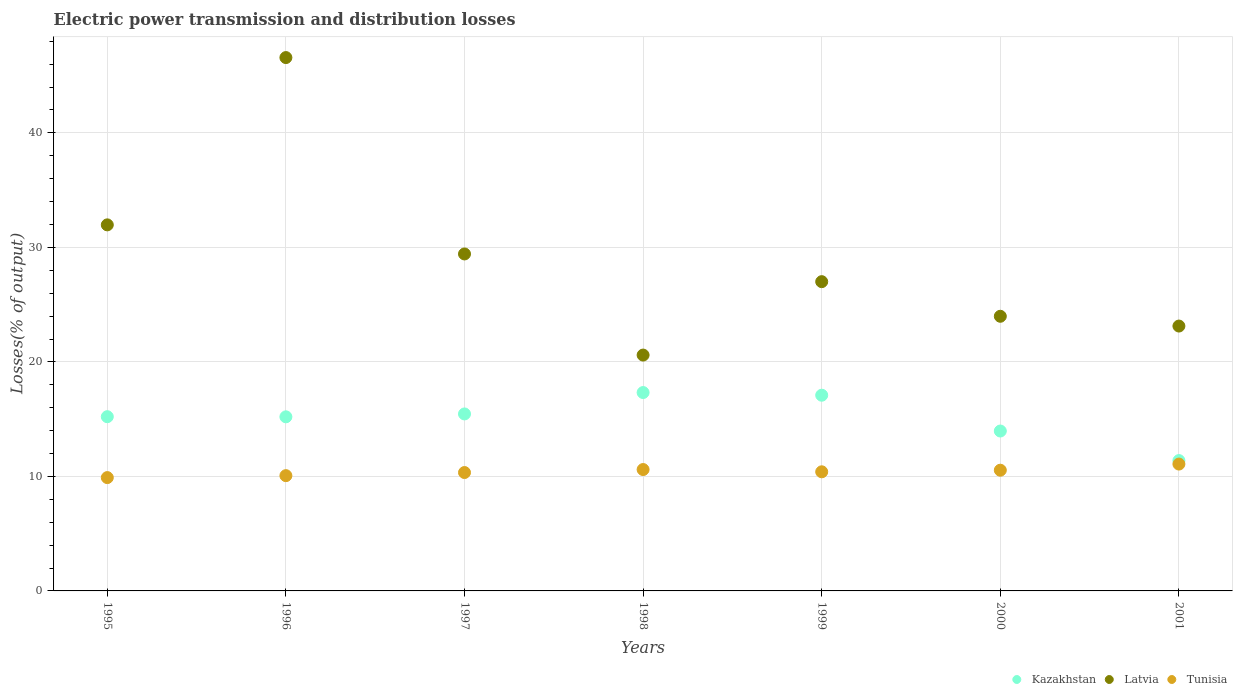Is the number of dotlines equal to the number of legend labels?
Keep it short and to the point. Yes. What is the electric power transmission and distribution losses in Kazakhstan in 1998?
Offer a very short reply. 17.32. Across all years, what is the maximum electric power transmission and distribution losses in Kazakhstan?
Ensure brevity in your answer.  17.32. Across all years, what is the minimum electric power transmission and distribution losses in Tunisia?
Ensure brevity in your answer.  9.9. In which year was the electric power transmission and distribution losses in Kazakhstan maximum?
Keep it short and to the point. 1998. What is the total electric power transmission and distribution losses in Latvia in the graph?
Your answer should be compact. 202.69. What is the difference between the electric power transmission and distribution losses in Kazakhstan in 1995 and that in 2001?
Provide a short and direct response. 3.83. What is the difference between the electric power transmission and distribution losses in Tunisia in 1995 and the electric power transmission and distribution losses in Kazakhstan in 2000?
Offer a terse response. -4.07. What is the average electric power transmission and distribution losses in Kazakhstan per year?
Your answer should be very brief. 15.09. In the year 1997, what is the difference between the electric power transmission and distribution losses in Tunisia and electric power transmission and distribution losses in Latvia?
Your response must be concise. -19.09. What is the ratio of the electric power transmission and distribution losses in Latvia in 1996 to that in 1999?
Offer a terse response. 1.72. What is the difference between the highest and the second highest electric power transmission and distribution losses in Latvia?
Your answer should be very brief. 14.61. What is the difference between the highest and the lowest electric power transmission and distribution losses in Tunisia?
Your response must be concise. 1.18. Is it the case that in every year, the sum of the electric power transmission and distribution losses in Latvia and electric power transmission and distribution losses in Tunisia  is greater than the electric power transmission and distribution losses in Kazakhstan?
Give a very brief answer. Yes. Is the electric power transmission and distribution losses in Latvia strictly greater than the electric power transmission and distribution losses in Tunisia over the years?
Ensure brevity in your answer.  Yes. How many dotlines are there?
Your answer should be very brief. 3. How many years are there in the graph?
Offer a very short reply. 7. What is the difference between two consecutive major ticks on the Y-axis?
Offer a very short reply. 10. Does the graph contain any zero values?
Offer a terse response. No. Where does the legend appear in the graph?
Offer a terse response. Bottom right. How many legend labels are there?
Your answer should be very brief. 3. How are the legend labels stacked?
Your answer should be compact. Horizontal. What is the title of the graph?
Offer a terse response. Electric power transmission and distribution losses. What is the label or title of the X-axis?
Your response must be concise. Years. What is the label or title of the Y-axis?
Give a very brief answer. Losses(% of output). What is the Losses(% of output) in Kazakhstan in 1995?
Offer a terse response. 15.22. What is the Losses(% of output) of Latvia in 1995?
Make the answer very short. 31.97. What is the Losses(% of output) of Tunisia in 1995?
Provide a short and direct response. 9.9. What is the Losses(% of output) in Kazakhstan in 1996?
Your answer should be compact. 15.2. What is the Losses(% of output) of Latvia in 1996?
Keep it short and to the point. 46.58. What is the Losses(% of output) in Tunisia in 1996?
Your answer should be very brief. 10.07. What is the Losses(% of output) of Kazakhstan in 1997?
Offer a terse response. 15.46. What is the Losses(% of output) in Latvia in 1997?
Ensure brevity in your answer.  29.43. What is the Losses(% of output) of Tunisia in 1997?
Your answer should be very brief. 10.34. What is the Losses(% of output) in Kazakhstan in 1998?
Ensure brevity in your answer.  17.32. What is the Losses(% of output) in Latvia in 1998?
Keep it short and to the point. 20.6. What is the Losses(% of output) of Tunisia in 1998?
Your answer should be very brief. 10.6. What is the Losses(% of output) of Kazakhstan in 1999?
Keep it short and to the point. 17.09. What is the Losses(% of output) of Latvia in 1999?
Provide a succinct answer. 27.01. What is the Losses(% of output) of Tunisia in 1999?
Offer a very short reply. 10.4. What is the Losses(% of output) of Kazakhstan in 2000?
Offer a very short reply. 13.96. What is the Losses(% of output) in Latvia in 2000?
Give a very brief answer. 23.98. What is the Losses(% of output) in Tunisia in 2000?
Offer a terse response. 10.54. What is the Losses(% of output) of Kazakhstan in 2001?
Ensure brevity in your answer.  11.38. What is the Losses(% of output) of Latvia in 2001?
Keep it short and to the point. 23.13. What is the Losses(% of output) of Tunisia in 2001?
Your answer should be very brief. 11.08. Across all years, what is the maximum Losses(% of output) in Kazakhstan?
Your answer should be very brief. 17.32. Across all years, what is the maximum Losses(% of output) in Latvia?
Give a very brief answer. 46.58. Across all years, what is the maximum Losses(% of output) of Tunisia?
Give a very brief answer. 11.08. Across all years, what is the minimum Losses(% of output) in Kazakhstan?
Your answer should be compact. 11.38. Across all years, what is the minimum Losses(% of output) in Latvia?
Ensure brevity in your answer.  20.6. Across all years, what is the minimum Losses(% of output) in Tunisia?
Offer a terse response. 9.9. What is the total Losses(% of output) of Kazakhstan in the graph?
Offer a terse response. 105.64. What is the total Losses(% of output) of Latvia in the graph?
Your answer should be compact. 202.69. What is the total Losses(% of output) of Tunisia in the graph?
Provide a succinct answer. 72.92. What is the difference between the Losses(% of output) in Kazakhstan in 1995 and that in 1996?
Your response must be concise. 0.01. What is the difference between the Losses(% of output) in Latvia in 1995 and that in 1996?
Your response must be concise. -14.61. What is the difference between the Losses(% of output) of Tunisia in 1995 and that in 1996?
Your answer should be very brief. -0.17. What is the difference between the Losses(% of output) in Kazakhstan in 1995 and that in 1997?
Give a very brief answer. -0.24. What is the difference between the Losses(% of output) of Latvia in 1995 and that in 1997?
Keep it short and to the point. 2.54. What is the difference between the Losses(% of output) in Tunisia in 1995 and that in 1997?
Keep it short and to the point. -0.44. What is the difference between the Losses(% of output) in Kazakhstan in 1995 and that in 1998?
Provide a short and direct response. -2.11. What is the difference between the Losses(% of output) of Latvia in 1995 and that in 1998?
Your answer should be very brief. 11.37. What is the difference between the Losses(% of output) of Tunisia in 1995 and that in 1998?
Your answer should be very brief. -0.7. What is the difference between the Losses(% of output) of Kazakhstan in 1995 and that in 1999?
Offer a terse response. -1.88. What is the difference between the Losses(% of output) in Latvia in 1995 and that in 1999?
Keep it short and to the point. 4.96. What is the difference between the Losses(% of output) in Tunisia in 1995 and that in 1999?
Your answer should be very brief. -0.51. What is the difference between the Losses(% of output) in Kazakhstan in 1995 and that in 2000?
Ensure brevity in your answer.  1.25. What is the difference between the Losses(% of output) in Latvia in 1995 and that in 2000?
Ensure brevity in your answer.  7.98. What is the difference between the Losses(% of output) in Tunisia in 1995 and that in 2000?
Offer a very short reply. -0.64. What is the difference between the Losses(% of output) in Kazakhstan in 1995 and that in 2001?
Offer a very short reply. 3.83. What is the difference between the Losses(% of output) in Latvia in 1995 and that in 2001?
Make the answer very short. 8.84. What is the difference between the Losses(% of output) of Tunisia in 1995 and that in 2001?
Your response must be concise. -1.18. What is the difference between the Losses(% of output) in Kazakhstan in 1996 and that in 1997?
Provide a short and direct response. -0.25. What is the difference between the Losses(% of output) in Latvia in 1996 and that in 1997?
Offer a terse response. 17.15. What is the difference between the Losses(% of output) in Tunisia in 1996 and that in 1997?
Your answer should be compact. -0.27. What is the difference between the Losses(% of output) in Kazakhstan in 1996 and that in 1998?
Offer a terse response. -2.12. What is the difference between the Losses(% of output) of Latvia in 1996 and that in 1998?
Provide a succinct answer. 25.98. What is the difference between the Losses(% of output) of Tunisia in 1996 and that in 1998?
Keep it short and to the point. -0.53. What is the difference between the Losses(% of output) of Kazakhstan in 1996 and that in 1999?
Ensure brevity in your answer.  -1.89. What is the difference between the Losses(% of output) in Latvia in 1996 and that in 1999?
Keep it short and to the point. 19.57. What is the difference between the Losses(% of output) of Tunisia in 1996 and that in 1999?
Provide a succinct answer. -0.34. What is the difference between the Losses(% of output) in Kazakhstan in 1996 and that in 2000?
Offer a terse response. 1.24. What is the difference between the Losses(% of output) of Latvia in 1996 and that in 2000?
Give a very brief answer. 22.59. What is the difference between the Losses(% of output) in Tunisia in 1996 and that in 2000?
Offer a very short reply. -0.47. What is the difference between the Losses(% of output) in Kazakhstan in 1996 and that in 2001?
Provide a short and direct response. 3.82. What is the difference between the Losses(% of output) of Latvia in 1996 and that in 2001?
Provide a succinct answer. 23.45. What is the difference between the Losses(% of output) in Tunisia in 1996 and that in 2001?
Give a very brief answer. -1.01. What is the difference between the Losses(% of output) in Kazakhstan in 1997 and that in 1998?
Give a very brief answer. -1.87. What is the difference between the Losses(% of output) of Latvia in 1997 and that in 1998?
Offer a very short reply. 8.83. What is the difference between the Losses(% of output) in Tunisia in 1997 and that in 1998?
Provide a short and direct response. -0.26. What is the difference between the Losses(% of output) of Kazakhstan in 1997 and that in 1999?
Your answer should be very brief. -1.64. What is the difference between the Losses(% of output) of Latvia in 1997 and that in 1999?
Offer a terse response. 2.42. What is the difference between the Losses(% of output) of Tunisia in 1997 and that in 1999?
Provide a short and direct response. -0.06. What is the difference between the Losses(% of output) in Kazakhstan in 1997 and that in 2000?
Make the answer very short. 1.49. What is the difference between the Losses(% of output) of Latvia in 1997 and that in 2000?
Your answer should be very brief. 5.44. What is the difference between the Losses(% of output) of Tunisia in 1997 and that in 2000?
Offer a terse response. -0.2. What is the difference between the Losses(% of output) of Kazakhstan in 1997 and that in 2001?
Provide a short and direct response. 4.07. What is the difference between the Losses(% of output) of Latvia in 1997 and that in 2001?
Offer a terse response. 6.3. What is the difference between the Losses(% of output) in Tunisia in 1997 and that in 2001?
Ensure brevity in your answer.  -0.74. What is the difference between the Losses(% of output) of Kazakhstan in 1998 and that in 1999?
Offer a terse response. 0.23. What is the difference between the Losses(% of output) in Latvia in 1998 and that in 1999?
Keep it short and to the point. -6.41. What is the difference between the Losses(% of output) in Tunisia in 1998 and that in 1999?
Provide a short and direct response. 0.2. What is the difference between the Losses(% of output) in Kazakhstan in 1998 and that in 2000?
Offer a very short reply. 3.36. What is the difference between the Losses(% of output) of Latvia in 1998 and that in 2000?
Offer a very short reply. -3.39. What is the difference between the Losses(% of output) of Tunisia in 1998 and that in 2000?
Offer a terse response. 0.06. What is the difference between the Losses(% of output) in Kazakhstan in 1998 and that in 2001?
Ensure brevity in your answer.  5.94. What is the difference between the Losses(% of output) in Latvia in 1998 and that in 2001?
Your response must be concise. -2.53. What is the difference between the Losses(% of output) of Tunisia in 1998 and that in 2001?
Your answer should be very brief. -0.48. What is the difference between the Losses(% of output) of Kazakhstan in 1999 and that in 2000?
Your response must be concise. 3.13. What is the difference between the Losses(% of output) in Latvia in 1999 and that in 2000?
Your answer should be very brief. 3.02. What is the difference between the Losses(% of output) in Tunisia in 1999 and that in 2000?
Offer a very short reply. -0.14. What is the difference between the Losses(% of output) of Kazakhstan in 1999 and that in 2001?
Ensure brevity in your answer.  5.71. What is the difference between the Losses(% of output) of Latvia in 1999 and that in 2001?
Offer a terse response. 3.88. What is the difference between the Losses(% of output) in Tunisia in 1999 and that in 2001?
Offer a terse response. -0.67. What is the difference between the Losses(% of output) in Kazakhstan in 2000 and that in 2001?
Offer a terse response. 2.58. What is the difference between the Losses(% of output) of Latvia in 2000 and that in 2001?
Ensure brevity in your answer.  0.85. What is the difference between the Losses(% of output) in Tunisia in 2000 and that in 2001?
Give a very brief answer. -0.54. What is the difference between the Losses(% of output) in Kazakhstan in 1995 and the Losses(% of output) in Latvia in 1996?
Your answer should be very brief. -31.36. What is the difference between the Losses(% of output) of Kazakhstan in 1995 and the Losses(% of output) of Tunisia in 1996?
Make the answer very short. 5.15. What is the difference between the Losses(% of output) of Latvia in 1995 and the Losses(% of output) of Tunisia in 1996?
Ensure brevity in your answer.  21.9. What is the difference between the Losses(% of output) of Kazakhstan in 1995 and the Losses(% of output) of Latvia in 1997?
Your answer should be very brief. -14.21. What is the difference between the Losses(% of output) of Kazakhstan in 1995 and the Losses(% of output) of Tunisia in 1997?
Offer a terse response. 4.88. What is the difference between the Losses(% of output) in Latvia in 1995 and the Losses(% of output) in Tunisia in 1997?
Offer a very short reply. 21.63. What is the difference between the Losses(% of output) in Kazakhstan in 1995 and the Losses(% of output) in Latvia in 1998?
Your response must be concise. -5.38. What is the difference between the Losses(% of output) in Kazakhstan in 1995 and the Losses(% of output) in Tunisia in 1998?
Give a very brief answer. 4.62. What is the difference between the Losses(% of output) in Latvia in 1995 and the Losses(% of output) in Tunisia in 1998?
Your response must be concise. 21.37. What is the difference between the Losses(% of output) in Kazakhstan in 1995 and the Losses(% of output) in Latvia in 1999?
Ensure brevity in your answer.  -11.79. What is the difference between the Losses(% of output) in Kazakhstan in 1995 and the Losses(% of output) in Tunisia in 1999?
Offer a terse response. 4.81. What is the difference between the Losses(% of output) of Latvia in 1995 and the Losses(% of output) of Tunisia in 1999?
Provide a short and direct response. 21.56. What is the difference between the Losses(% of output) of Kazakhstan in 1995 and the Losses(% of output) of Latvia in 2000?
Your answer should be compact. -8.77. What is the difference between the Losses(% of output) of Kazakhstan in 1995 and the Losses(% of output) of Tunisia in 2000?
Give a very brief answer. 4.67. What is the difference between the Losses(% of output) in Latvia in 1995 and the Losses(% of output) in Tunisia in 2000?
Ensure brevity in your answer.  21.43. What is the difference between the Losses(% of output) of Kazakhstan in 1995 and the Losses(% of output) of Latvia in 2001?
Provide a succinct answer. -7.92. What is the difference between the Losses(% of output) in Kazakhstan in 1995 and the Losses(% of output) in Tunisia in 2001?
Give a very brief answer. 4.14. What is the difference between the Losses(% of output) of Latvia in 1995 and the Losses(% of output) of Tunisia in 2001?
Your answer should be compact. 20.89. What is the difference between the Losses(% of output) in Kazakhstan in 1996 and the Losses(% of output) in Latvia in 1997?
Ensure brevity in your answer.  -14.22. What is the difference between the Losses(% of output) of Kazakhstan in 1996 and the Losses(% of output) of Tunisia in 1997?
Your answer should be very brief. 4.87. What is the difference between the Losses(% of output) of Latvia in 1996 and the Losses(% of output) of Tunisia in 1997?
Your response must be concise. 36.24. What is the difference between the Losses(% of output) in Kazakhstan in 1996 and the Losses(% of output) in Latvia in 1998?
Make the answer very short. -5.39. What is the difference between the Losses(% of output) of Kazakhstan in 1996 and the Losses(% of output) of Tunisia in 1998?
Keep it short and to the point. 4.6. What is the difference between the Losses(% of output) of Latvia in 1996 and the Losses(% of output) of Tunisia in 1998?
Your answer should be very brief. 35.98. What is the difference between the Losses(% of output) in Kazakhstan in 1996 and the Losses(% of output) in Latvia in 1999?
Your answer should be compact. -11.8. What is the difference between the Losses(% of output) of Kazakhstan in 1996 and the Losses(% of output) of Tunisia in 1999?
Offer a very short reply. 4.8. What is the difference between the Losses(% of output) of Latvia in 1996 and the Losses(% of output) of Tunisia in 1999?
Keep it short and to the point. 36.17. What is the difference between the Losses(% of output) in Kazakhstan in 1996 and the Losses(% of output) in Latvia in 2000?
Your answer should be very brief. -8.78. What is the difference between the Losses(% of output) of Kazakhstan in 1996 and the Losses(% of output) of Tunisia in 2000?
Provide a short and direct response. 4.66. What is the difference between the Losses(% of output) in Latvia in 1996 and the Losses(% of output) in Tunisia in 2000?
Offer a very short reply. 36.04. What is the difference between the Losses(% of output) of Kazakhstan in 1996 and the Losses(% of output) of Latvia in 2001?
Provide a succinct answer. -7.93. What is the difference between the Losses(% of output) in Kazakhstan in 1996 and the Losses(% of output) in Tunisia in 2001?
Provide a short and direct response. 4.13. What is the difference between the Losses(% of output) of Latvia in 1996 and the Losses(% of output) of Tunisia in 2001?
Ensure brevity in your answer.  35.5. What is the difference between the Losses(% of output) of Kazakhstan in 1997 and the Losses(% of output) of Latvia in 1998?
Make the answer very short. -5.14. What is the difference between the Losses(% of output) in Kazakhstan in 1997 and the Losses(% of output) in Tunisia in 1998?
Your answer should be compact. 4.86. What is the difference between the Losses(% of output) of Latvia in 1997 and the Losses(% of output) of Tunisia in 1998?
Keep it short and to the point. 18.83. What is the difference between the Losses(% of output) of Kazakhstan in 1997 and the Losses(% of output) of Latvia in 1999?
Provide a succinct answer. -11.55. What is the difference between the Losses(% of output) in Kazakhstan in 1997 and the Losses(% of output) in Tunisia in 1999?
Provide a short and direct response. 5.05. What is the difference between the Losses(% of output) in Latvia in 1997 and the Losses(% of output) in Tunisia in 1999?
Provide a succinct answer. 19.02. What is the difference between the Losses(% of output) in Kazakhstan in 1997 and the Losses(% of output) in Latvia in 2000?
Your answer should be very brief. -8.53. What is the difference between the Losses(% of output) of Kazakhstan in 1997 and the Losses(% of output) of Tunisia in 2000?
Your response must be concise. 4.91. What is the difference between the Losses(% of output) of Latvia in 1997 and the Losses(% of output) of Tunisia in 2000?
Offer a terse response. 18.89. What is the difference between the Losses(% of output) in Kazakhstan in 1997 and the Losses(% of output) in Latvia in 2001?
Ensure brevity in your answer.  -7.68. What is the difference between the Losses(% of output) of Kazakhstan in 1997 and the Losses(% of output) of Tunisia in 2001?
Offer a very short reply. 4.38. What is the difference between the Losses(% of output) in Latvia in 1997 and the Losses(% of output) in Tunisia in 2001?
Your answer should be very brief. 18.35. What is the difference between the Losses(% of output) of Kazakhstan in 1998 and the Losses(% of output) of Latvia in 1999?
Ensure brevity in your answer.  -9.68. What is the difference between the Losses(% of output) of Kazakhstan in 1998 and the Losses(% of output) of Tunisia in 1999?
Your answer should be very brief. 6.92. What is the difference between the Losses(% of output) of Latvia in 1998 and the Losses(% of output) of Tunisia in 1999?
Your answer should be compact. 10.19. What is the difference between the Losses(% of output) of Kazakhstan in 1998 and the Losses(% of output) of Latvia in 2000?
Make the answer very short. -6.66. What is the difference between the Losses(% of output) in Kazakhstan in 1998 and the Losses(% of output) in Tunisia in 2000?
Provide a short and direct response. 6.78. What is the difference between the Losses(% of output) of Latvia in 1998 and the Losses(% of output) of Tunisia in 2000?
Provide a short and direct response. 10.06. What is the difference between the Losses(% of output) in Kazakhstan in 1998 and the Losses(% of output) in Latvia in 2001?
Provide a short and direct response. -5.81. What is the difference between the Losses(% of output) in Kazakhstan in 1998 and the Losses(% of output) in Tunisia in 2001?
Your answer should be compact. 6.25. What is the difference between the Losses(% of output) of Latvia in 1998 and the Losses(% of output) of Tunisia in 2001?
Keep it short and to the point. 9.52. What is the difference between the Losses(% of output) of Kazakhstan in 1999 and the Losses(% of output) of Latvia in 2000?
Ensure brevity in your answer.  -6.89. What is the difference between the Losses(% of output) of Kazakhstan in 1999 and the Losses(% of output) of Tunisia in 2000?
Your answer should be very brief. 6.55. What is the difference between the Losses(% of output) of Latvia in 1999 and the Losses(% of output) of Tunisia in 2000?
Offer a very short reply. 16.47. What is the difference between the Losses(% of output) of Kazakhstan in 1999 and the Losses(% of output) of Latvia in 2001?
Ensure brevity in your answer.  -6.04. What is the difference between the Losses(% of output) in Kazakhstan in 1999 and the Losses(% of output) in Tunisia in 2001?
Ensure brevity in your answer.  6.01. What is the difference between the Losses(% of output) in Latvia in 1999 and the Losses(% of output) in Tunisia in 2001?
Offer a terse response. 15.93. What is the difference between the Losses(% of output) in Kazakhstan in 2000 and the Losses(% of output) in Latvia in 2001?
Your response must be concise. -9.17. What is the difference between the Losses(% of output) in Kazakhstan in 2000 and the Losses(% of output) in Tunisia in 2001?
Your answer should be very brief. 2.89. What is the difference between the Losses(% of output) of Latvia in 2000 and the Losses(% of output) of Tunisia in 2001?
Your response must be concise. 12.91. What is the average Losses(% of output) in Kazakhstan per year?
Provide a succinct answer. 15.09. What is the average Losses(% of output) in Latvia per year?
Your response must be concise. 28.96. What is the average Losses(% of output) in Tunisia per year?
Provide a succinct answer. 10.42. In the year 1995, what is the difference between the Losses(% of output) of Kazakhstan and Losses(% of output) of Latvia?
Offer a terse response. -16.75. In the year 1995, what is the difference between the Losses(% of output) of Kazakhstan and Losses(% of output) of Tunisia?
Your answer should be compact. 5.32. In the year 1995, what is the difference between the Losses(% of output) in Latvia and Losses(% of output) in Tunisia?
Provide a short and direct response. 22.07. In the year 1996, what is the difference between the Losses(% of output) in Kazakhstan and Losses(% of output) in Latvia?
Your answer should be compact. -31.37. In the year 1996, what is the difference between the Losses(% of output) of Kazakhstan and Losses(% of output) of Tunisia?
Offer a terse response. 5.14. In the year 1996, what is the difference between the Losses(% of output) of Latvia and Losses(% of output) of Tunisia?
Provide a succinct answer. 36.51. In the year 1997, what is the difference between the Losses(% of output) of Kazakhstan and Losses(% of output) of Latvia?
Offer a terse response. -13.97. In the year 1997, what is the difference between the Losses(% of output) of Kazakhstan and Losses(% of output) of Tunisia?
Provide a short and direct response. 5.12. In the year 1997, what is the difference between the Losses(% of output) in Latvia and Losses(% of output) in Tunisia?
Your answer should be very brief. 19.09. In the year 1998, what is the difference between the Losses(% of output) of Kazakhstan and Losses(% of output) of Latvia?
Your answer should be very brief. -3.27. In the year 1998, what is the difference between the Losses(% of output) in Kazakhstan and Losses(% of output) in Tunisia?
Make the answer very short. 6.72. In the year 1998, what is the difference between the Losses(% of output) in Latvia and Losses(% of output) in Tunisia?
Make the answer very short. 10. In the year 1999, what is the difference between the Losses(% of output) in Kazakhstan and Losses(% of output) in Latvia?
Make the answer very short. -9.92. In the year 1999, what is the difference between the Losses(% of output) in Kazakhstan and Losses(% of output) in Tunisia?
Ensure brevity in your answer.  6.69. In the year 1999, what is the difference between the Losses(% of output) in Latvia and Losses(% of output) in Tunisia?
Provide a succinct answer. 16.6. In the year 2000, what is the difference between the Losses(% of output) of Kazakhstan and Losses(% of output) of Latvia?
Ensure brevity in your answer.  -10.02. In the year 2000, what is the difference between the Losses(% of output) of Kazakhstan and Losses(% of output) of Tunisia?
Ensure brevity in your answer.  3.42. In the year 2000, what is the difference between the Losses(% of output) in Latvia and Losses(% of output) in Tunisia?
Offer a very short reply. 13.44. In the year 2001, what is the difference between the Losses(% of output) of Kazakhstan and Losses(% of output) of Latvia?
Make the answer very short. -11.75. In the year 2001, what is the difference between the Losses(% of output) of Kazakhstan and Losses(% of output) of Tunisia?
Offer a terse response. 0.3. In the year 2001, what is the difference between the Losses(% of output) of Latvia and Losses(% of output) of Tunisia?
Your response must be concise. 12.05. What is the ratio of the Losses(% of output) of Latvia in 1995 to that in 1996?
Your answer should be very brief. 0.69. What is the ratio of the Losses(% of output) of Tunisia in 1995 to that in 1996?
Offer a terse response. 0.98. What is the ratio of the Losses(% of output) of Kazakhstan in 1995 to that in 1997?
Offer a terse response. 0.98. What is the ratio of the Losses(% of output) in Latvia in 1995 to that in 1997?
Offer a terse response. 1.09. What is the ratio of the Losses(% of output) in Tunisia in 1995 to that in 1997?
Offer a terse response. 0.96. What is the ratio of the Losses(% of output) of Kazakhstan in 1995 to that in 1998?
Provide a short and direct response. 0.88. What is the ratio of the Losses(% of output) of Latvia in 1995 to that in 1998?
Offer a terse response. 1.55. What is the ratio of the Losses(% of output) of Tunisia in 1995 to that in 1998?
Your answer should be compact. 0.93. What is the ratio of the Losses(% of output) in Kazakhstan in 1995 to that in 1999?
Your answer should be very brief. 0.89. What is the ratio of the Losses(% of output) in Latvia in 1995 to that in 1999?
Offer a terse response. 1.18. What is the ratio of the Losses(% of output) in Tunisia in 1995 to that in 1999?
Ensure brevity in your answer.  0.95. What is the ratio of the Losses(% of output) in Kazakhstan in 1995 to that in 2000?
Make the answer very short. 1.09. What is the ratio of the Losses(% of output) in Latvia in 1995 to that in 2000?
Give a very brief answer. 1.33. What is the ratio of the Losses(% of output) in Tunisia in 1995 to that in 2000?
Your answer should be compact. 0.94. What is the ratio of the Losses(% of output) of Kazakhstan in 1995 to that in 2001?
Your answer should be compact. 1.34. What is the ratio of the Losses(% of output) in Latvia in 1995 to that in 2001?
Provide a succinct answer. 1.38. What is the ratio of the Losses(% of output) in Tunisia in 1995 to that in 2001?
Your answer should be compact. 0.89. What is the ratio of the Losses(% of output) of Kazakhstan in 1996 to that in 1997?
Your response must be concise. 0.98. What is the ratio of the Losses(% of output) in Latvia in 1996 to that in 1997?
Provide a succinct answer. 1.58. What is the ratio of the Losses(% of output) of Tunisia in 1996 to that in 1997?
Your answer should be very brief. 0.97. What is the ratio of the Losses(% of output) in Kazakhstan in 1996 to that in 1998?
Provide a short and direct response. 0.88. What is the ratio of the Losses(% of output) of Latvia in 1996 to that in 1998?
Ensure brevity in your answer.  2.26. What is the ratio of the Losses(% of output) of Tunisia in 1996 to that in 1998?
Your answer should be very brief. 0.95. What is the ratio of the Losses(% of output) of Kazakhstan in 1996 to that in 1999?
Make the answer very short. 0.89. What is the ratio of the Losses(% of output) of Latvia in 1996 to that in 1999?
Offer a very short reply. 1.72. What is the ratio of the Losses(% of output) in Tunisia in 1996 to that in 1999?
Your answer should be compact. 0.97. What is the ratio of the Losses(% of output) in Kazakhstan in 1996 to that in 2000?
Provide a short and direct response. 1.09. What is the ratio of the Losses(% of output) in Latvia in 1996 to that in 2000?
Your answer should be very brief. 1.94. What is the ratio of the Losses(% of output) of Tunisia in 1996 to that in 2000?
Provide a short and direct response. 0.95. What is the ratio of the Losses(% of output) of Kazakhstan in 1996 to that in 2001?
Your answer should be very brief. 1.34. What is the ratio of the Losses(% of output) in Latvia in 1996 to that in 2001?
Offer a terse response. 2.01. What is the ratio of the Losses(% of output) of Tunisia in 1996 to that in 2001?
Keep it short and to the point. 0.91. What is the ratio of the Losses(% of output) of Kazakhstan in 1997 to that in 1998?
Give a very brief answer. 0.89. What is the ratio of the Losses(% of output) of Latvia in 1997 to that in 1998?
Provide a short and direct response. 1.43. What is the ratio of the Losses(% of output) of Tunisia in 1997 to that in 1998?
Keep it short and to the point. 0.98. What is the ratio of the Losses(% of output) in Kazakhstan in 1997 to that in 1999?
Keep it short and to the point. 0.9. What is the ratio of the Losses(% of output) of Latvia in 1997 to that in 1999?
Offer a very short reply. 1.09. What is the ratio of the Losses(% of output) of Kazakhstan in 1997 to that in 2000?
Ensure brevity in your answer.  1.11. What is the ratio of the Losses(% of output) in Latvia in 1997 to that in 2000?
Make the answer very short. 1.23. What is the ratio of the Losses(% of output) in Tunisia in 1997 to that in 2000?
Ensure brevity in your answer.  0.98. What is the ratio of the Losses(% of output) of Kazakhstan in 1997 to that in 2001?
Provide a succinct answer. 1.36. What is the ratio of the Losses(% of output) of Latvia in 1997 to that in 2001?
Your answer should be very brief. 1.27. What is the ratio of the Losses(% of output) in Tunisia in 1997 to that in 2001?
Offer a very short reply. 0.93. What is the ratio of the Losses(% of output) of Kazakhstan in 1998 to that in 1999?
Make the answer very short. 1.01. What is the ratio of the Losses(% of output) in Latvia in 1998 to that in 1999?
Offer a terse response. 0.76. What is the ratio of the Losses(% of output) of Tunisia in 1998 to that in 1999?
Provide a short and direct response. 1.02. What is the ratio of the Losses(% of output) of Kazakhstan in 1998 to that in 2000?
Ensure brevity in your answer.  1.24. What is the ratio of the Losses(% of output) of Latvia in 1998 to that in 2000?
Offer a terse response. 0.86. What is the ratio of the Losses(% of output) in Tunisia in 1998 to that in 2000?
Make the answer very short. 1.01. What is the ratio of the Losses(% of output) in Kazakhstan in 1998 to that in 2001?
Give a very brief answer. 1.52. What is the ratio of the Losses(% of output) of Latvia in 1998 to that in 2001?
Provide a short and direct response. 0.89. What is the ratio of the Losses(% of output) in Tunisia in 1998 to that in 2001?
Your answer should be compact. 0.96. What is the ratio of the Losses(% of output) of Kazakhstan in 1999 to that in 2000?
Offer a very short reply. 1.22. What is the ratio of the Losses(% of output) of Latvia in 1999 to that in 2000?
Offer a very short reply. 1.13. What is the ratio of the Losses(% of output) of Tunisia in 1999 to that in 2000?
Your answer should be compact. 0.99. What is the ratio of the Losses(% of output) in Kazakhstan in 1999 to that in 2001?
Give a very brief answer. 1.5. What is the ratio of the Losses(% of output) in Latvia in 1999 to that in 2001?
Your response must be concise. 1.17. What is the ratio of the Losses(% of output) in Tunisia in 1999 to that in 2001?
Offer a very short reply. 0.94. What is the ratio of the Losses(% of output) of Kazakhstan in 2000 to that in 2001?
Your answer should be very brief. 1.23. What is the ratio of the Losses(% of output) of Latvia in 2000 to that in 2001?
Provide a short and direct response. 1.04. What is the ratio of the Losses(% of output) in Tunisia in 2000 to that in 2001?
Provide a short and direct response. 0.95. What is the difference between the highest and the second highest Losses(% of output) of Kazakhstan?
Give a very brief answer. 0.23. What is the difference between the highest and the second highest Losses(% of output) in Latvia?
Offer a very short reply. 14.61. What is the difference between the highest and the second highest Losses(% of output) in Tunisia?
Provide a short and direct response. 0.48. What is the difference between the highest and the lowest Losses(% of output) of Kazakhstan?
Provide a short and direct response. 5.94. What is the difference between the highest and the lowest Losses(% of output) of Latvia?
Provide a succinct answer. 25.98. What is the difference between the highest and the lowest Losses(% of output) in Tunisia?
Your response must be concise. 1.18. 